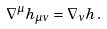Convert formula to latex. <formula><loc_0><loc_0><loc_500><loc_500>\nabla ^ { \mu } h _ { \mu \nu } = \nabla _ { \nu } h \, .</formula> 